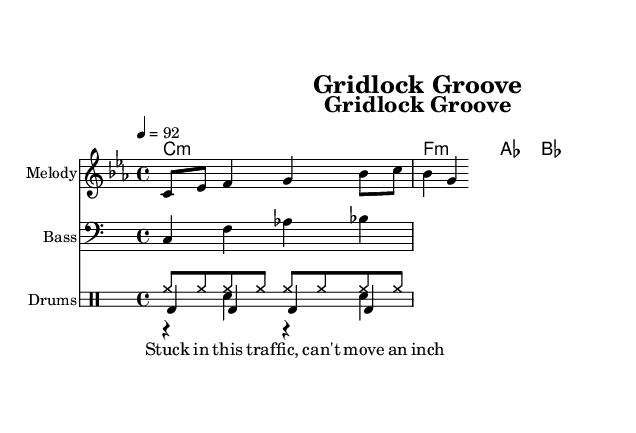What is the key signature of this music? The key signature is C minor, as indicated by the "c" in the key signature symbol at the beginning of the score. C minor has three flats in its key signature, which correspond to the notes E flat, A flat, and B flat.
Answer: C minor What is the time signature of this piece? The time signature is 4/4, shown in the score where it specifies how there are four beats in each measure and each quarter note gets one beat.
Answer: 4/4 What is the tempo marking indicated in the score? The tempo marking shows that the piece is to be played at a speed of 92 beats per minute, as indicated by "4 = 92" following the tempo indication in the score.
Answer: 92 How many measures are in the melody provided? The melody consists of four measures, which can be counted by looking at the grouping of notes separated visually by measure lines in the staff.
Answer: 4 What type of music is represented in this sheet? This piece represents rap music as indicated by the theme of transportation mishaps and the structure as a humorous lyric-driven piece, which aligns with rap characteristics.
Answer: Rap What instruments are included in the score? The score includes three instruments: a melodic staff, a bass staff, and a drum staff, each indicated by their respective instrument names in the sheet music.
Answer: Melody, Bass, Drums What is the first lyric line written in the score? The first lyric line in the score is "Stuck in this traf -- fic, can't move an inch," which is written directly below the melodic staff.
Answer: Stuck in this traf -- fic, can't move an inch 